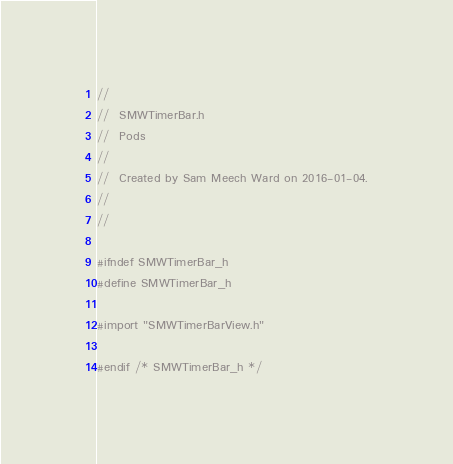Convert code to text. <code><loc_0><loc_0><loc_500><loc_500><_C_>//
//  SMWTimerBar.h
//  Pods
//
//  Created by Sam Meech Ward on 2016-01-04.
//
//

#ifndef SMWTimerBar_h
#define SMWTimerBar_h

#import "SMWTimerBarView.h"

#endif /* SMWTimerBar_h */
</code> 